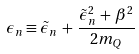<formula> <loc_0><loc_0><loc_500><loc_500>\epsilon _ { n } \equiv \tilde { \epsilon } _ { n } \, + \, \frac { \tilde { \epsilon } _ { n } ^ { 2 } \, + \, \beta ^ { 2 } } { 2 m _ { Q } }</formula> 